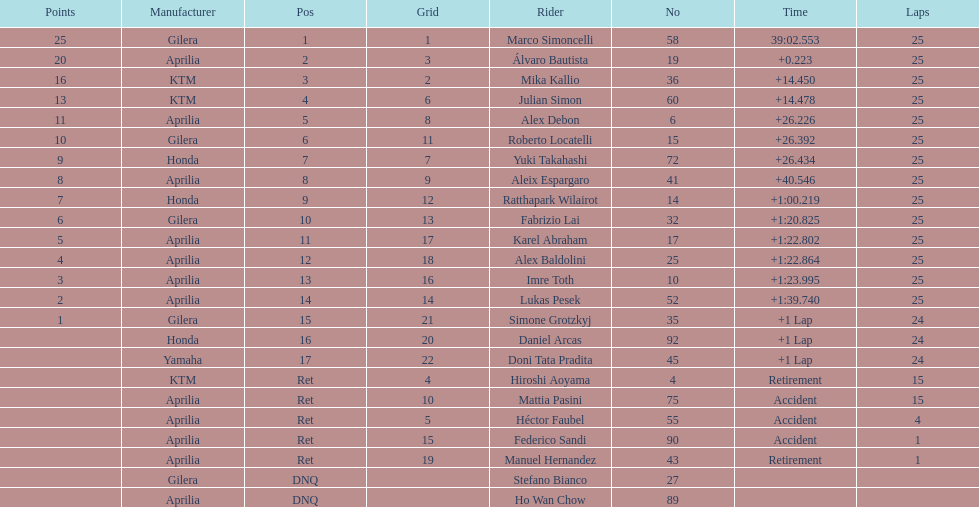What was the fastest overall time? 39:02.553. I'm looking to parse the entire table for insights. Could you assist me with that? {'header': ['Points', 'Manufacturer', 'Pos', 'Grid', 'Rider', 'No', 'Time', 'Laps'], 'rows': [['25', 'Gilera', '1', '1', 'Marco Simoncelli', '58', '39:02.553', '25'], ['20', 'Aprilia', '2', '3', 'Álvaro Bautista', '19', '+0.223', '25'], ['16', 'KTM', '3', '2', 'Mika Kallio', '36', '+14.450', '25'], ['13', 'KTM', '4', '6', 'Julian Simon', '60', '+14.478', '25'], ['11', 'Aprilia', '5', '8', 'Alex Debon', '6', '+26.226', '25'], ['10', 'Gilera', '6', '11', 'Roberto Locatelli', '15', '+26.392', '25'], ['9', 'Honda', '7', '7', 'Yuki Takahashi', '72', '+26.434', '25'], ['8', 'Aprilia', '8', '9', 'Aleix Espargaro', '41', '+40.546', '25'], ['7', 'Honda', '9', '12', 'Ratthapark Wilairot', '14', '+1:00.219', '25'], ['6', 'Gilera', '10', '13', 'Fabrizio Lai', '32', '+1:20.825', '25'], ['5', 'Aprilia', '11', '17', 'Karel Abraham', '17', '+1:22.802', '25'], ['4', 'Aprilia', '12', '18', 'Alex Baldolini', '25', '+1:22.864', '25'], ['3', 'Aprilia', '13', '16', 'Imre Toth', '10', '+1:23.995', '25'], ['2', 'Aprilia', '14', '14', 'Lukas Pesek', '52', '+1:39.740', '25'], ['1', 'Gilera', '15', '21', 'Simone Grotzkyj', '35', '+1 Lap', '24'], ['', 'Honda', '16', '20', 'Daniel Arcas', '92', '+1 Lap', '24'], ['', 'Yamaha', '17', '22', 'Doni Tata Pradita', '45', '+1 Lap', '24'], ['', 'KTM', 'Ret', '4', 'Hiroshi Aoyama', '4', 'Retirement', '15'], ['', 'Aprilia', 'Ret', '10', 'Mattia Pasini', '75', 'Accident', '15'], ['', 'Aprilia', 'Ret', '5', 'Héctor Faubel', '55', 'Accident', '4'], ['', 'Aprilia', 'Ret', '15', 'Federico Sandi', '90', 'Accident', '1'], ['', 'Aprilia', 'Ret', '19', 'Manuel Hernandez', '43', 'Retirement', '1'], ['', 'Gilera', 'DNQ', '', 'Stefano Bianco', '27', '', ''], ['', 'Aprilia', 'DNQ', '', 'Ho Wan Chow', '89', '', '']]} Who does this time belong to? Marco Simoncelli. 